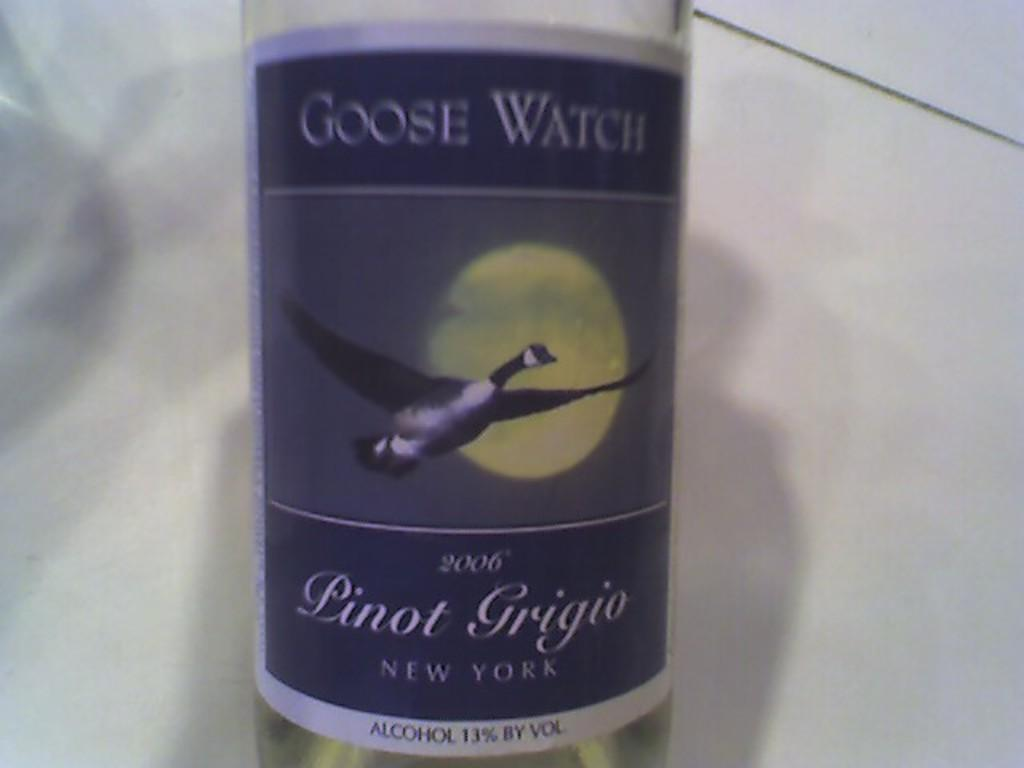<image>
Give a short and clear explanation of the subsequent image. A bottle of Goose Watch pinot grigio says it is from New York. 